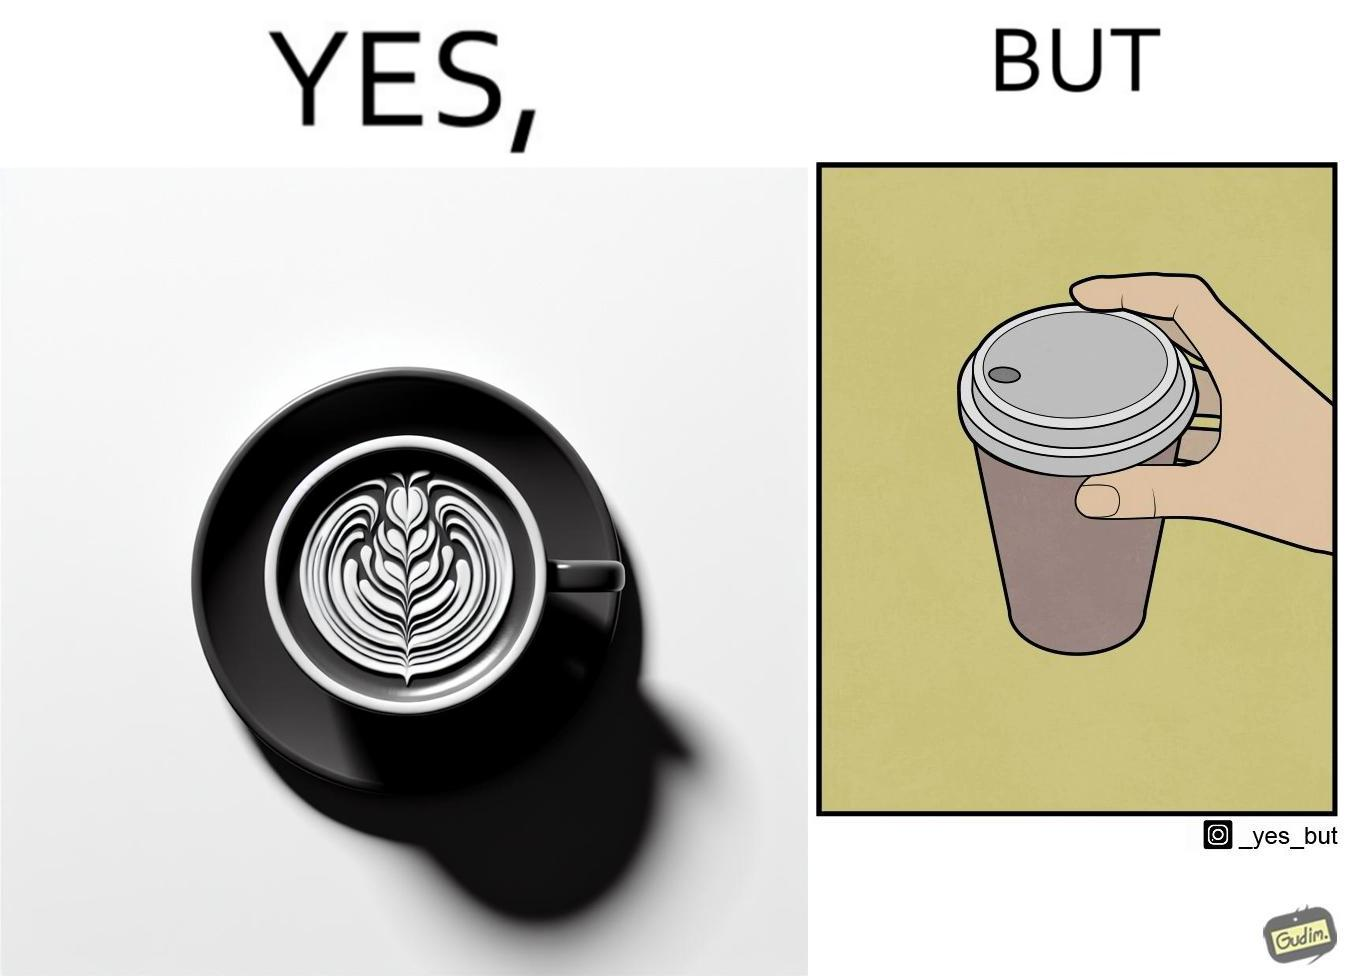Is this a satirical image? Yes, this image is satirical. 